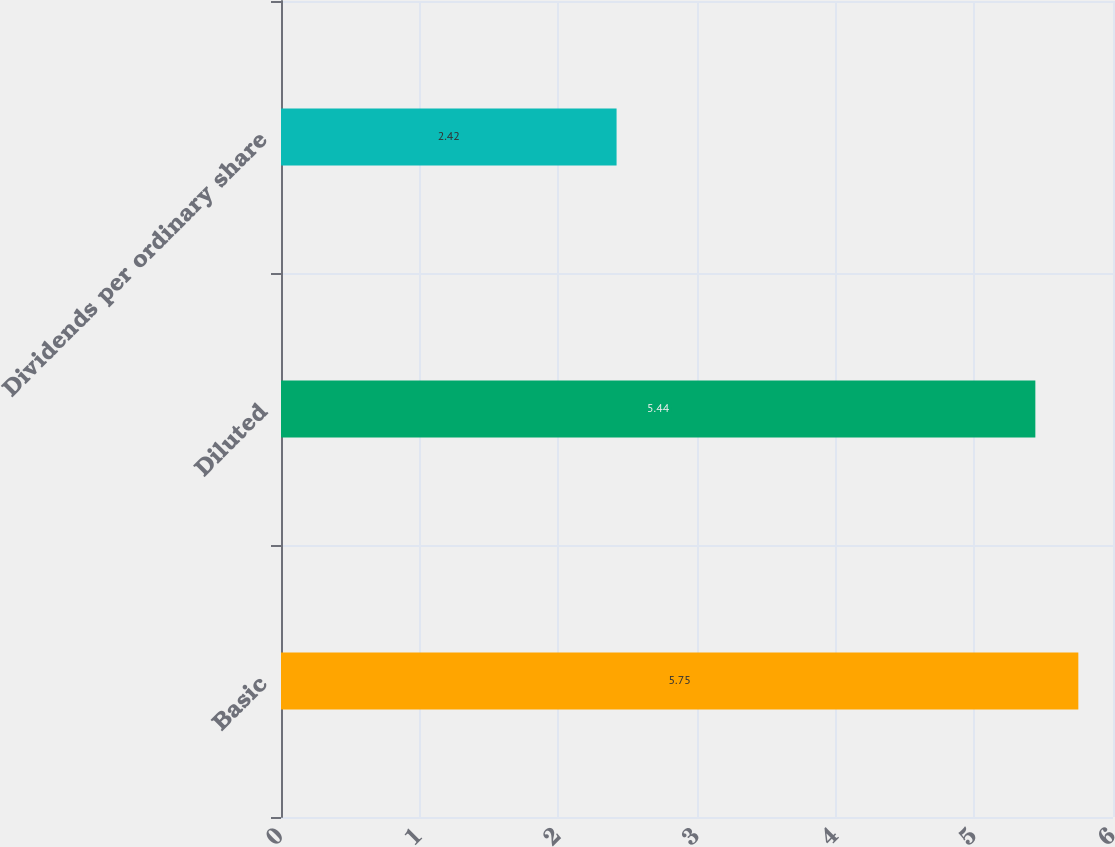<chart> <loc_0><loc_0><loc_500><loc_500><bar_chart><fcel>Basic<fcel>Diluted<fcel>Dividends per ordinary share<nl><fcel>5.75<fcel>5.44<fcel>2.42<nl></chart> 